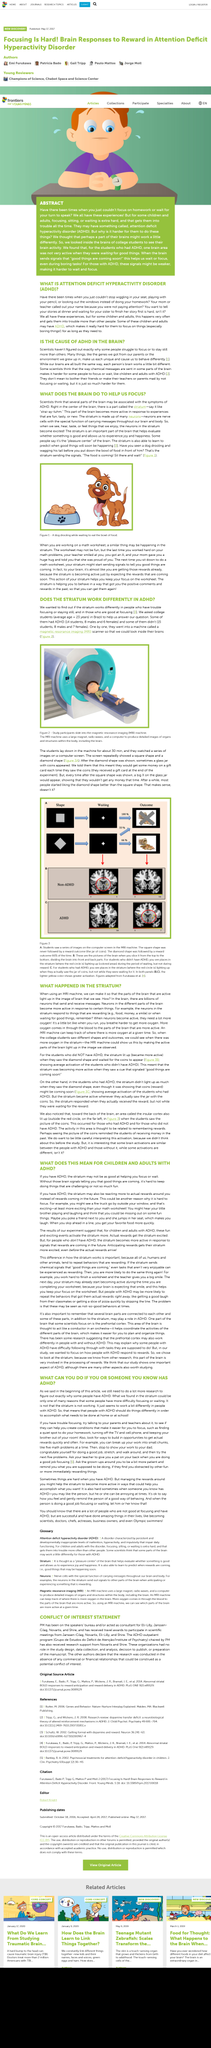Point out several critical features in this image. If one has ADHD, they should adapt their methods of completing tasks at home or school in order to effectively accomplish what needs to be done. The striatum works in people with ADHD, but differently than in people without ADHD. The content of this article is debating whether the root cause of ADHD is located in the brain. Scientists have not yet determined the exact reason why some people struggle to focus or stay still more than others. The condition name "ADHD" appears twice in the example, once in the title and once in the body of the paragraph. 